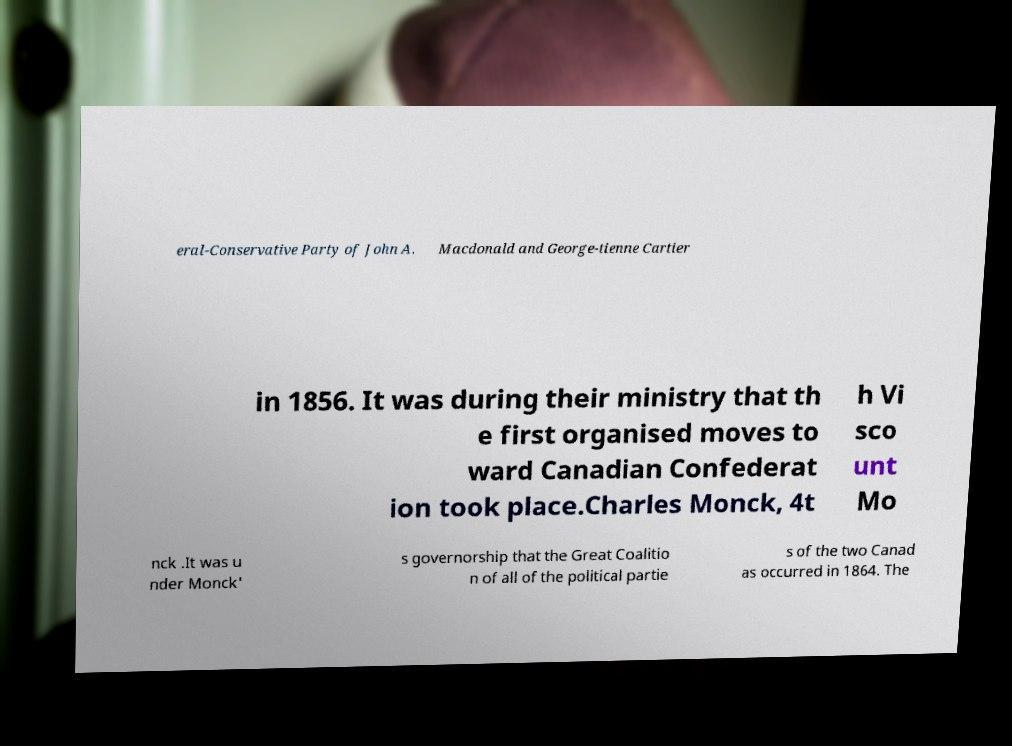Could you extract and type out the text from this image? eral-Conservative Party of John A. Macdonald and George-tienne Cartier in 1856. It was during their ministry that th e first organised moves to ward Canadian Confederat ion took place.Charles Monck, 4t h Vi sco unt Mo nck .It was u nder Monck' s governorship that the Great Coalitio n of all of the political partie s of the two Canad as occurred in 1864. The 